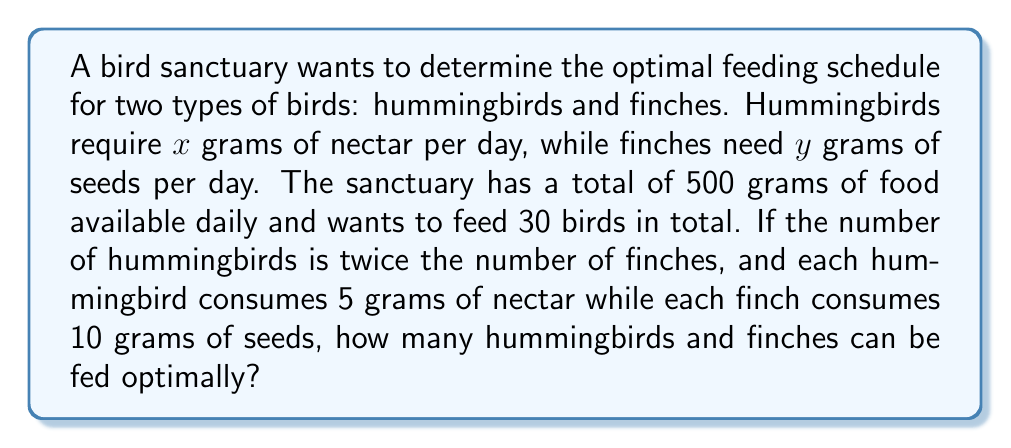Provide a solution to this math problem. Let's approach this step-by-step:

1) Let's define our variables:
   $h$ = number of hummingbirds
   $f$ = number of finches

2) We're given that the number of hummingbirds is twice the number of finches:
   $h = 2f$

3) We know the total number of birds is 30:
   $h + f = 30$

4) Substituting the first equation into the second:
   $2f + f = 30$
   $3f = 30$
   $f = 10$

5) Now we can find $h$:
   $h = 2f = 2(10) = 20$

6) Let's verify with our food constraints:
   Hummingbirds: $20 \times 5 = 100$ grams of nectar
   Finches: $10 \times 10 = 100$ grams of seeds
   Total: $100 + 100 = 200$ grams < 500 grams available

Therefore, this feeding schedule is optimal and within the available food supply.
Answer: 20 hummingbirds, 10 finches 